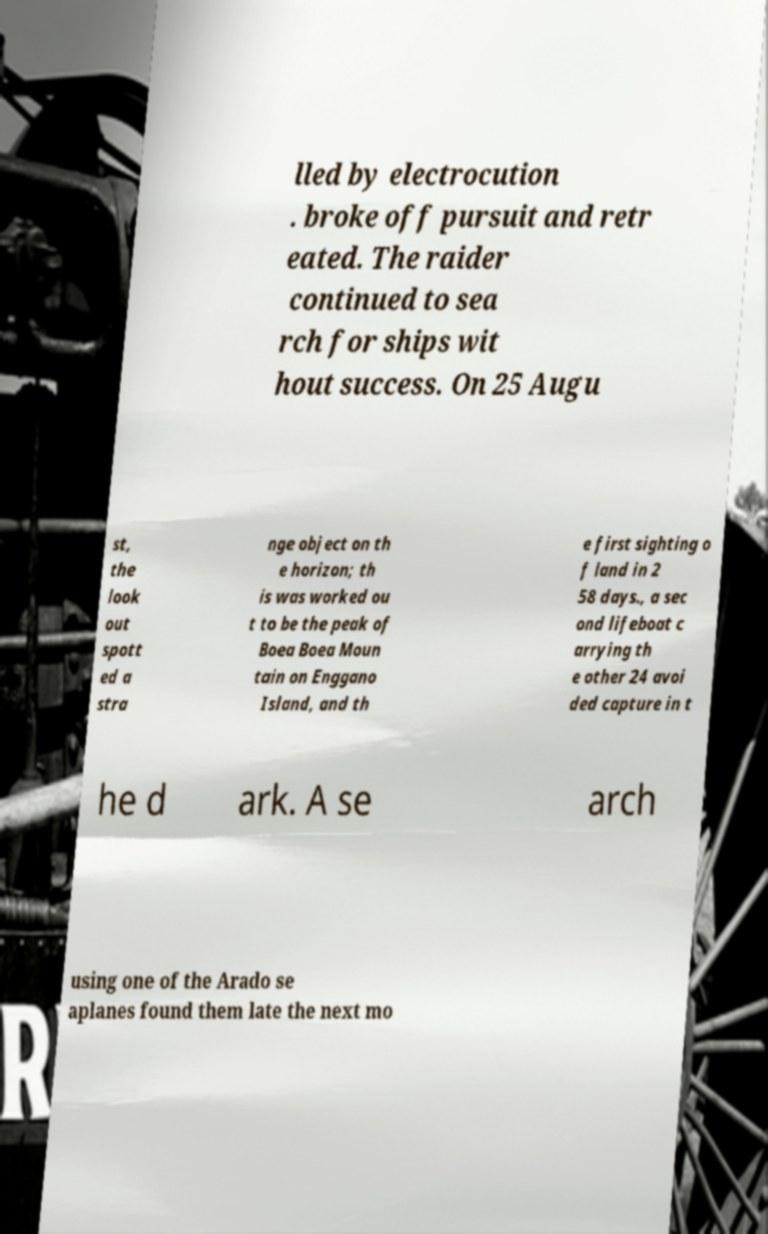There's text embedded in this image that I need extracted. Can you transcribe it verbatim? lled by electrocution . broke off pursuit and retr eated. The raider continued to sea rch for ships wit hout success. On 25 Augu st, the look out spott ed a stra nge object on th e horizon; th is was worked ou t to be the peak of Boea Boea Moun tain on Enggano Island, and th e first sighting o f land in 2 58 days., a sec ond lifeboat c arrying th e other 24 avoi ded capture in t he d ark. A se arch using one of the Arado se aplanes found them late the next mo 